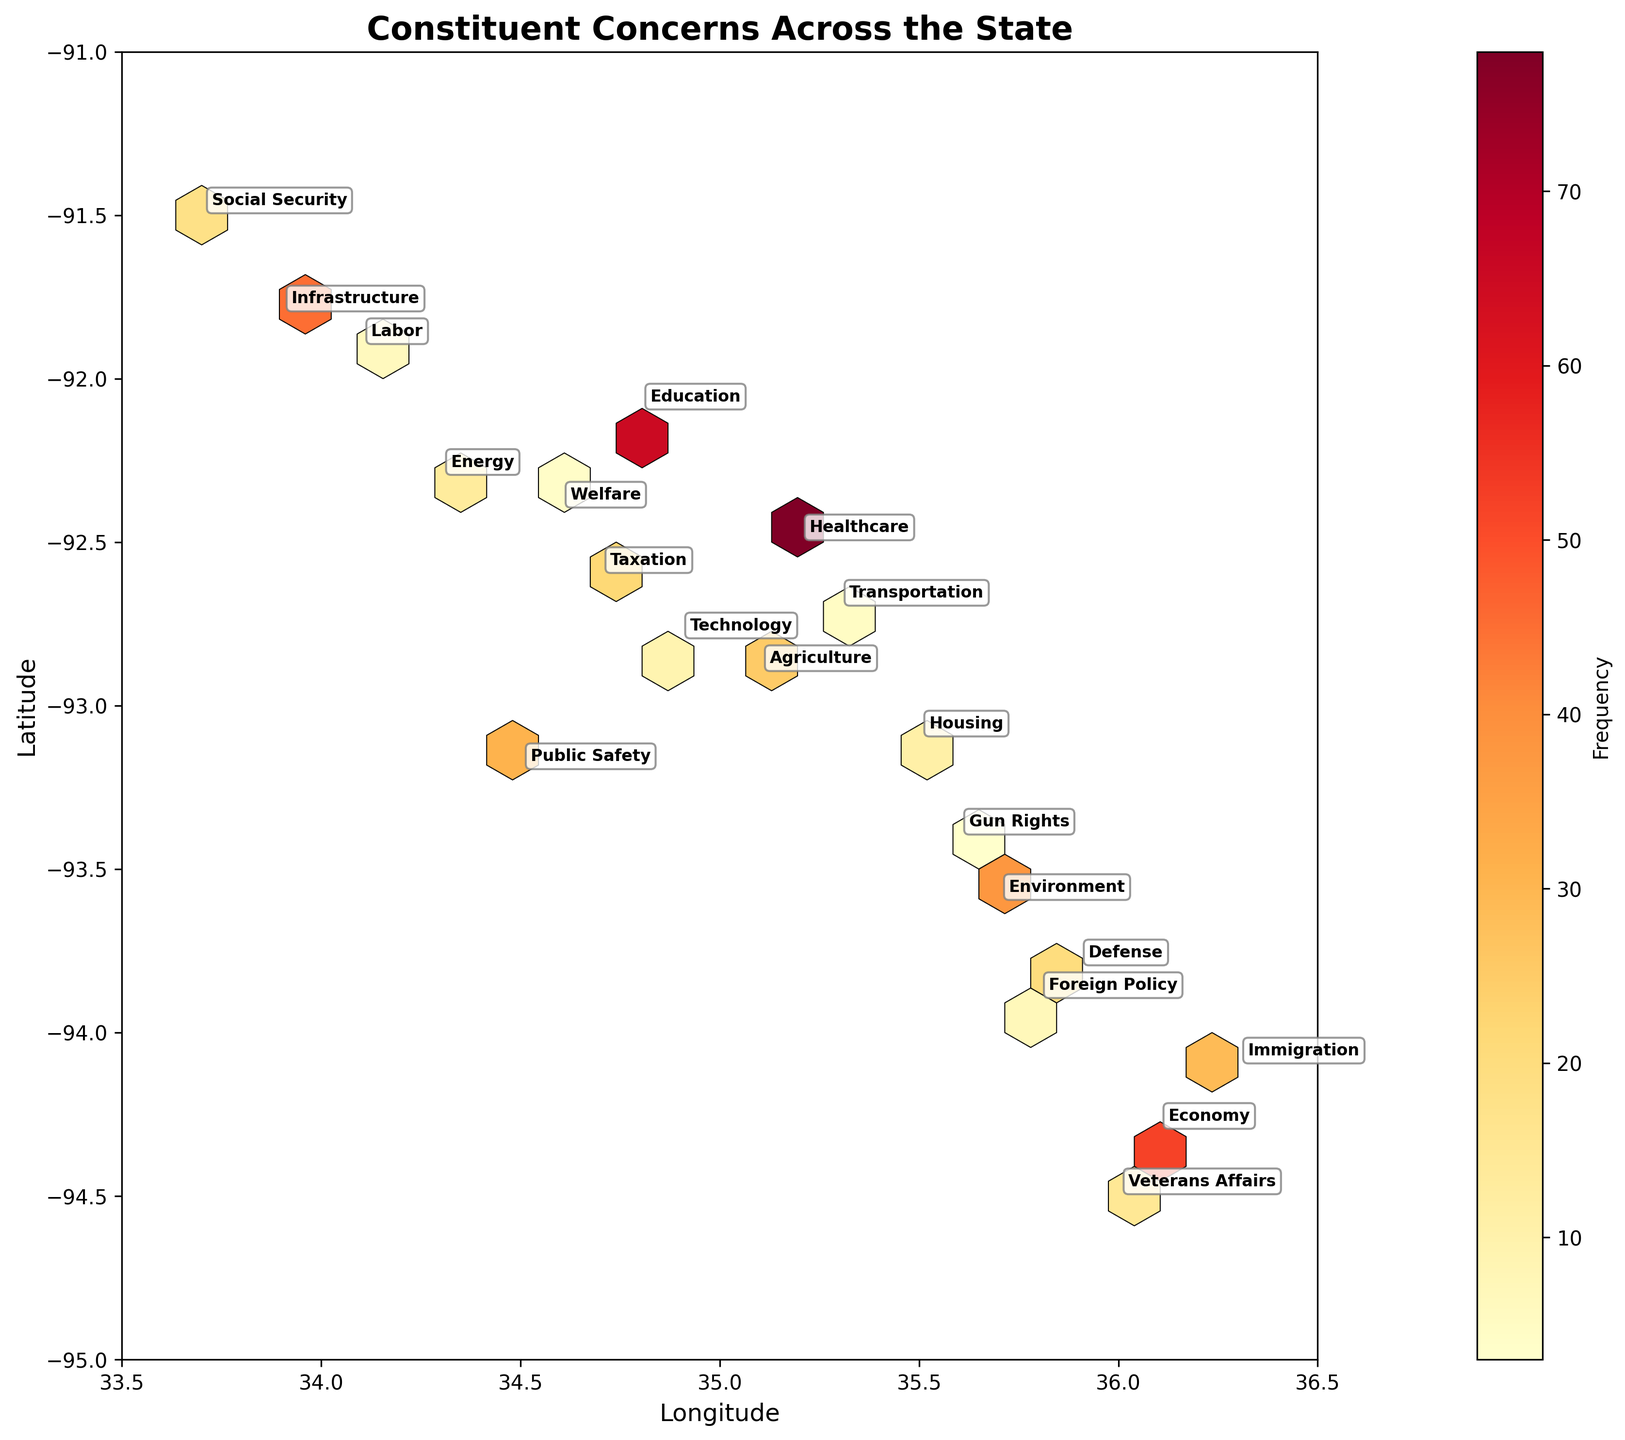What does the color intensity represent in the hexbin plot? The color intensity in a hexbin plot represents the frequency of the concerns in that area. Darker colors indicate higher frequencies.
Answer: Frequency What are the highest frequency and the corresponding policy area observed in the plot? The highest frequency is represented by the darkest hexagon, which corresponds to the Healthcare policy area with a frequency of 78.
Answer: 78, Healthcare Which policy areas are located around the latitude 35.5 and longitude -93? Policy areas near latitude 35.5 and longitude -93 include Environment, Housing, and Defense. This inference is made by looking at the annotations near this coordinate on the plot.
Answer: Environment, Housing, Defense How does the frequency of concerns related to Education compare to those related to Economy? The color intensity and annotation on the plot show that the frequency for Education is 65, whereas for Economy it is 52. Therefore, concerns related to Education are more frequent than those related to Economy.
Answer: Education > Economy What is the average frequency of policy areas with more than 20 concerns? Sum the frequencies of policy areas with more than 20 concerns: Healthcare (78), Education (65), Economy (52), Infrastructure (45), Environment (38), Public Safety (31), Public Safety (25), then divide this sum by the number of these policy areas (7). The total is 334, so the average is 334 / 7 ≈ 47.71
Answer: 47.71 Which policy area has the lowest frequency and what is its value? The plot annotations show that Gun Rights has the lowest frequency with a value of 3.
Answer: Gun Rights, 3 What region (in terms of latitude and longitude) has the highest frequency of concerns related to Environment? The annotation for Environment is found at latitude 35.7 and longitude -93.6, indicating this is the region with the highest frequency for this policy area.
Answer: 35.7, -93.6 Are there any policy areas with similar frequencies? If so, what are they? The plot shows that Veterans Affairs (15) and Energy (13) have similar frequencies, with only a slight difference. Additionally, Immigration (29) and Agriculture (25) are also relatively close in frequency.
Answer: Veterans Affairs, Energy; Immigration, Agriculture How does the distribution of concerns for Social Security compare spatially to that of Immigration? Social Security concerns are located around latitude 33.7 and longitude -91.5, while Immigration concerns are at latitude 36.3 and longitude -94.1. This indicates that the concerns for these policy areas are spread across significantly different regions of the state.
Answer: Different regions What can you infer about the regional distribution of concerns related to Defense and Foreign Policy? Annotations show that concerns for Defense are around latitude 35.9, longitude -93.8 and Foreign Policy at latitude 35.8, longitude -93.9. They are located close to each other, indicating concerns for these policy areas are regionally concentrated.
Answer: Close to each other 